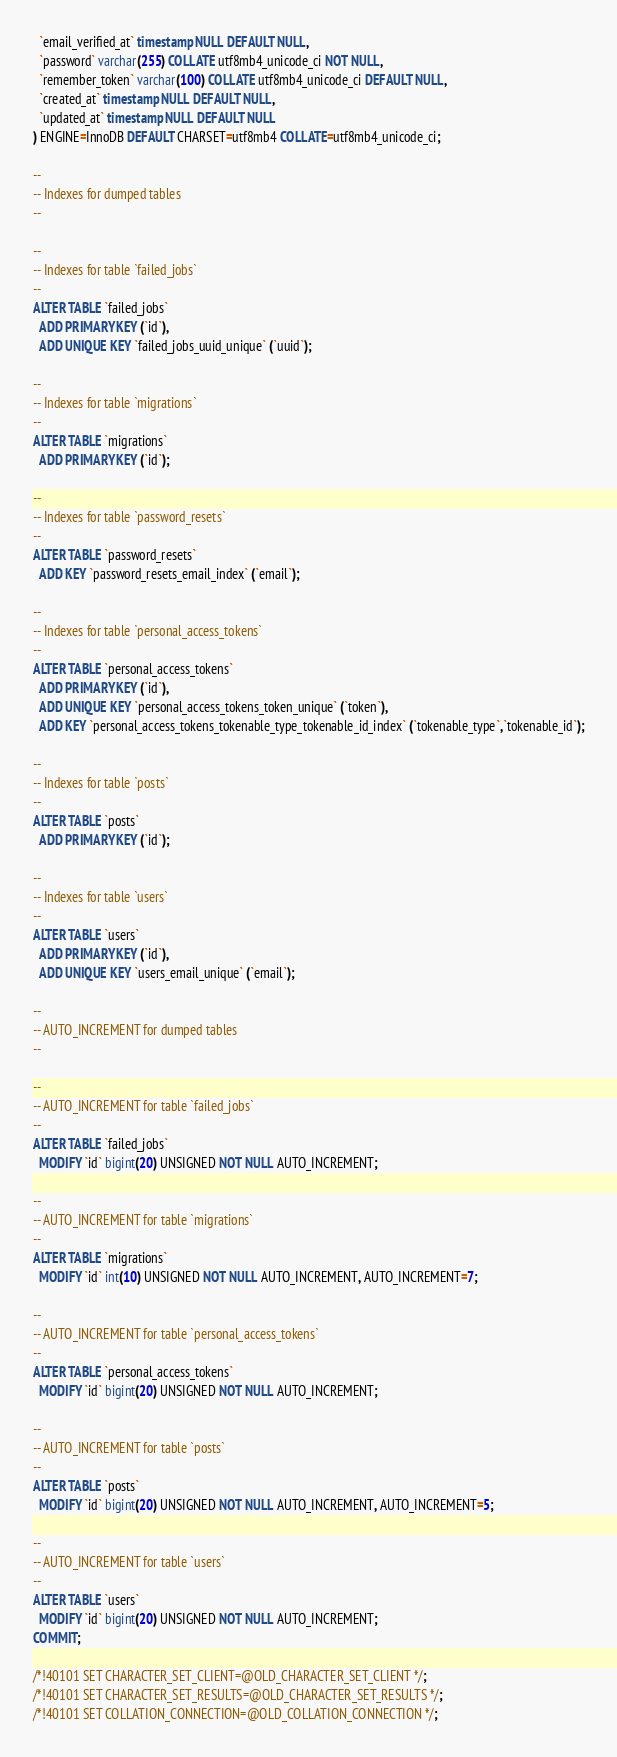Convert code to text. <code><loc_0><loc_0><loc_500><loc_500><_SQL_>  `email_verified_at` timestamp NULL DEFAULT NULL,
  `password` varchar(255) COLLATE utf8mb4_unicode_ci NOT NULL,
  `remember_token` varchar(100) COLLATE utf8mb4_unicode_ci DEFAULT NULL,
  `created_at` timestamp NULL DEFAULT NULL,
  `updated_at` timestamp NULL DEFAULT NULL
) ENGINE=InnoDB DEFAULT CHARSET=utf8mb4 COLLATE=utf8mb4_unicode_ci;

--
-- Indexes for dumped tables
--

--
-- Indexes for table `failed_jobs`
--
ALTER TABLE `failed_jobs`
  ADD PRIMARY KEY (`id`),
  ADD UNIQUE KEY `failed_jobs_uuid_unique` (`uuid`);

--
-- Indexes for table `migrations`
--
ALTER TABLE `migrations`
  ADD PRIMARY KEY (`id`);

--
-- Indexes for table `password_resets`
--
ALTER TABLE `password_resets`
  ADD KEY `password_resets_email_index` (`email`);

--
-- Indexes for table `personal_access_tokens`
--
ALTER TABLE `personal_access_tokens`
  ADD PRIMARY KEY (`id`),
  ADD UNIQUE KEY `personal_access_tokens_token_unique` (`token`),
  ADD KEY `personal_access_tokens_tokenable_type_tokenable_id_index` (`tokenable_type`,`tokenable_id`);

--
-- Indexes for table `posts`
--
ALTER TABLE `posts`
  ADD PRIMARY KEY (`id`);

--
-- Indexes for table `users`
--
ALTER TABLE `users`
  ADD PRIMARY KEY (`id`),
  ADD UNIQUE KEY `users_email_unique` (`email`);

--
-- AUTO_INCREMENT for dumped tables
--

--
-- AUTO_INCREMENT for table `failed_jobs`
--
ALTER TABLE `failed_jobs`
  MODIFY `id` bigint(20) UNSIGNED NOT NULL AUTO_INCREMENT;

--
-- AUTO_INCREMENT for table `migrations`
--
ALTER TABLE `migrations`
  MODIFY `id` int(10) UNSIGNED NOT NULL AUTO_INCREMENT, AUTO_INCREMENT=7;

--
-- AUTO_INCREMENT for table `personal_access_tokens`
--
ALTER TABLE `personal_access_tokens`
  MODIFY `id` bigint(20) UNSIGNED NOT NULL AUTO_INCREMENT;

--
-- AUTO_INCREMENT for table `posts`
--
ALTER TABLE `posts`
  MODIFY `id` bigint(20) UNSIGNED NOT NULL AUTO_INCREMENT, AUTO_INCREMENT=5;

--
-- AUTO_INCREMENT for table `users`
--
ALTER TABLE `users`
  MODIFY `id` bigint(20) UNSIGNED NOT NULL AUTO_INCREMENT;
COMMIT;

/*!40101 SET CHARACTER_SET_CLIENT=@OLD_CHARACTER_SET_CLIENT */;
/*!40101 SET CHARACTER_SET_RESULTS=@OLD_CHARACTER_SET_RESULTS */;
/*!40101 SET COLLATION_CONNECTION=@OLD_COLLATION_CONNECTION */;
</code> 